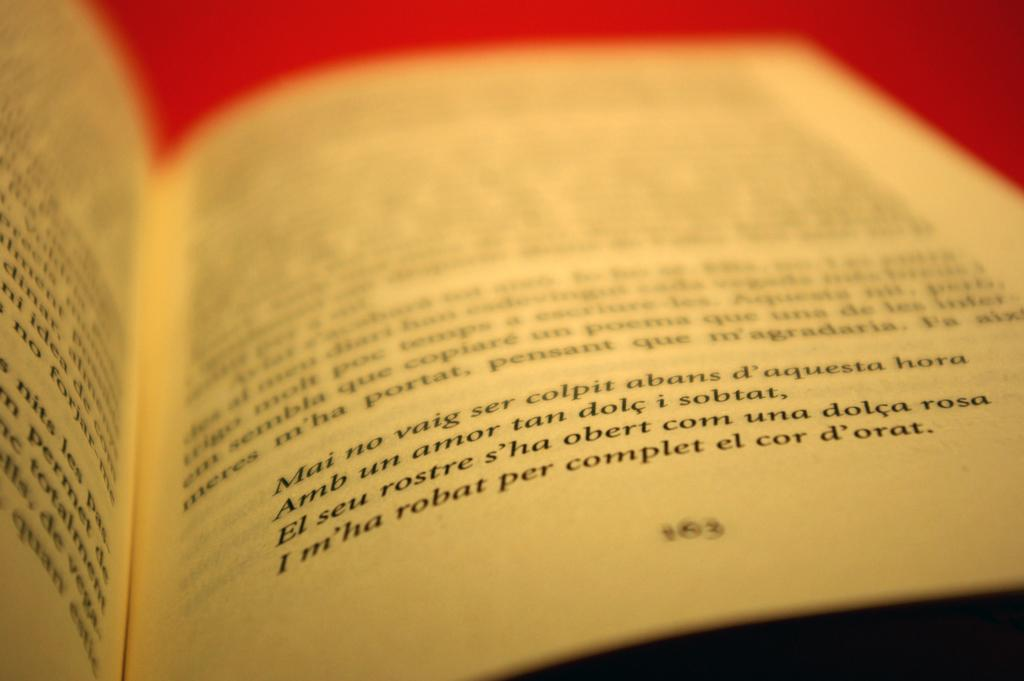<image>
Offer a succinct explanation of the picture presented. A book written in a language other than English is opened to page number 163. 